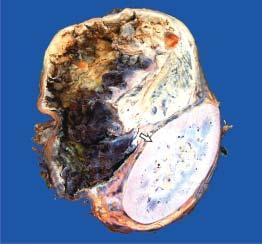what does the specimen show?
Answer the question using a single word or phrase. Compressed kidney at the lower end 